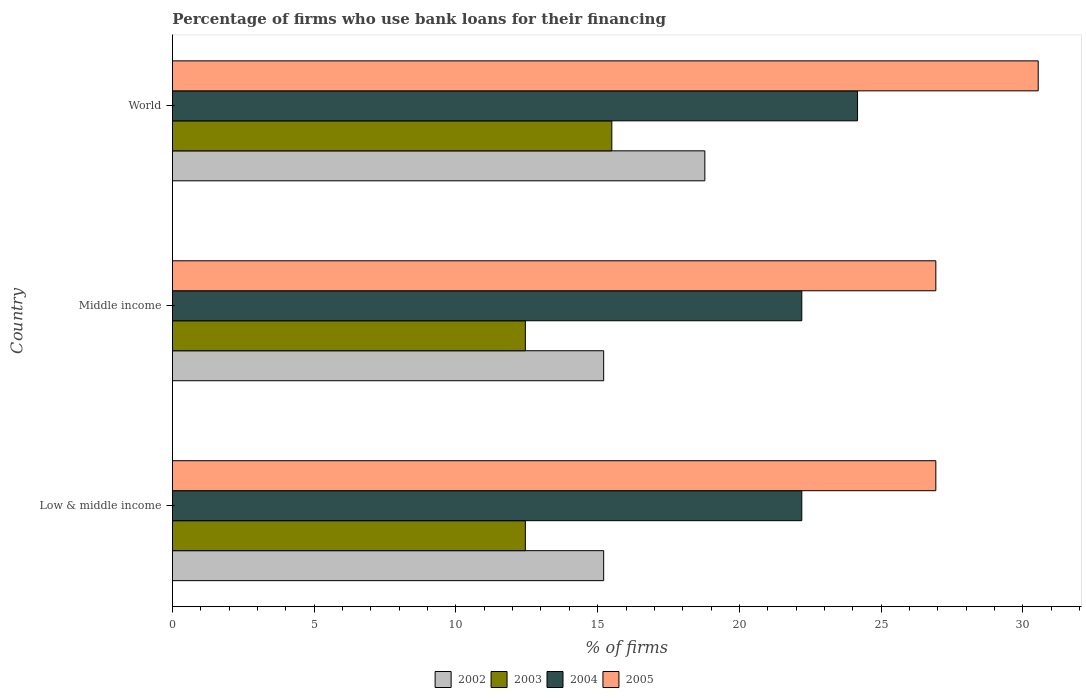How many different coloured bars are there?
Keep it short and to the point. 4. Are the number of bars per tick equal to the number of legend labels?
Provide a short and direct response. Yes. How many bars are there on the 1st tick from the top?
Provide a short and direct response. 4. What is the percentage of firms who use bank loans for their financing in 2003 in Low & middle income?
Offer a terse response. 12.45. Across all countries, what is the maximum percentage of firms who use bank loans for their financing in 2002?
Provide a succinct answer. 18.78. Across all countries, what is the minimum percentage of firms who use bank loans for their financing in 2004?
Offer a terse response. 22.2. In which country was the percentage of firms who use bank loans for their financing in 2003 minimum?
Keep it short and to the point. Low & middle income. What is the total percentage of firms who use bank loans for their financing in 2005 in the graph?
Ensure brevity in your answer.  84.39. What is the difference between the percentage of firms who use bank loans for their financing in 2004 in Middle income and that in World?
Keep it short and to the point. -1.97. What is the difference between the percentage of firms who use bank loans for their financing in 2002 in World and the percentage of firms who use bank loans for their financing in 2005 in Low & middle income?
Your response must be concise. -8.15. What is the average percentage of firms who use bank loans for their financing in 2002 per country?
Offer a very short reply. 16.4. What is the difference between the percentage of firms who use bank loans for their financing in 2003 and percentage of firms who use bank loans for their financing in 2005 in World?
Your answer should be compact. -15.04. Is the percentage of firms who use bank loans for their financing in 2004 in Low & middle income less than that in World?
Your response must be concise. Yes. Is the difference between the percentage of firms who use bank loans for their financing in 2003 in Middle income and World greater than the difference between the percentage of firms who use bank loans for their financing in 2005 in Middle income and World?
Your response must be concise. Yes. What is the difference between the highest and the second highest percentage of firms who use bank loans for their financing in 2003?
Provide a succinct answer. 3.05. What is the difference between the highest and the lowest percentage of firms who use bank loans for their financing in 2003?
Provide a succinct answer. 3.05. In how many countries, is the percentage of firms who use bank loans for their financing in 2005 greater than the average percentage of firms who use bank loans for their financing in 2005 taken over all countries?
Provide a short and direct response. 1. What does the 1st bar from the top in World represents?
Provide a short and direct response. 2005. Is it the case that in every country, the sum of the percentage of firms who use bank loans for their financing in 2002 and percentage of firms who use bank loans for their financing in 2005 is greater than the percentage of firms who use bank loans for their financing in 2003?
Keep it short and to the point. Yes. Are all the bars in the graph horizontal?
Your answer should be compact. Yes. Does the graph contain any zero values?
Provide a short and direct response. No. Does the graph contain grids?
Keep it short and to the point. No. Where does the legend appear in the graph?
Offer a terse response. Bottom center. How many legend labels are there?
Provide a succinct answer. 4. What is the title of the graph?
Your answer should be very brief. Percentage of firms who use bank loans for their financing. Does "1983" appear as one of the legend labels in the graph?
Keep it short and to the point. No. What is the label or title of the X-axis?
Offer a terse response. % of firms. What is the label or title of the Y-axis?
Keep it short and to the point. Country. What is the % of firms of 2002 in Low & middle income?
Your answer should be very brief. 15.21. What is the % of firms in 2003 in Low & middle income?
Your answer should be very brief. 12.45. What is the % of firms in 2005 in Low & middle income?
Your response must be concise. 26.93. What is the % of firms in 2002 in Middle income?
Provide a succinct answer. 15.21. What is the % of firms in 2003 in Middle income?
Your answer should be compact. 12.45. What is the % of firms in 2004 in Middle income?
Your response must be concise. 22.2. What is the % of firms of 2005 in Middle income?
Give a very brief answer. 26.93. What is the % of firms of 2002 in World?
Ensure brevity in your answer.  18.78. What is the % of firms of 2004 in World?
Give a very brief answer. 24.17. What is the % of firms of 2005 in World?
Your answer should be compact. 30.54. Across all countries, what is the maximum % of firms in 2002?
Ensure brevity in your answer.  18.78. Across all countries, what is the maximum % of firms of 2003?
Your answer should be very brief. 15.5. Across all countries, what is the maximum % of firms in 2004?
Your answer should be compact. 24.17. Across all countries, what is the maximum % of firms of 2005?
Give a very brief answer. 30.54. Across all countries, what is the minimum % of firms in 2002?
Ensure brevity in your answer.  15.21. Across all countries, what is the minimum % of firms of 2003?
Provide a short and direct response. 12.45. Across all countries, what is the minimum % of firms of 2005?
Make the answer very short. 26.93. What is the total % of firms of 2002 in the graph?
Make the answer very short. 49.21. What is the total % of firms in 2003 in the graph?
Your answer should be compact. 40.4. What is the total % of firms of 2004 in the graph?
Your answer should be very brief. 68.57. What is the total % of firms in 2005 in the graph?
Offer a very short reply. 84.39. What is the difference between the % of firms of 2003 in Low & middle income and that in Middle income?
Keep it short and to the point. 0. What is the difference between the % of firms of 2004 in Low & middle income and that in Middle income?
Provide a short and direct response. 0. What is the difference between the % of firms of 2002 in Low & middle income and that in World?
Offer a very short reply. -3.57. What is the difference between the % of firms in 2003 in Low & middle income and that in World?
Provide a short and direct response. -3.05. What is the difference between the % of firms of 2004 in Low & middle income and that in World?
Ensure brevity in your answer.  -1.97. What is the difference between the % of firms of 2005 in Low & middle income and that in World?
Ensure brevity in your answer.  -3.61. What is the difference between the % of firms of 2002 in Middle income and that in World?
Keep it short and to the point. -3.57. What is the difference between the % of firms of 2003 in Middle income and that in World?
Keep it short and to the point. -3.05. What is the difference between the % of firms in 2004 in Middle income and that in World?
Offer a very short reply. -1.97. What is the difference between the % of firms of 2005 in Middle income and that in World?
Offer a very short reply. -3.61. What is the difference between the % of firms in 2002 in Low & middle income and the % of firms in 2003 in Middle income?
Provide a succinct answer. 2.76. What is the difference between the % of firms in 2002 in Low & middle income and the % of firms in 2004 in Middle income?
Provide a succinct answer. -6.99. What is the difference between the % of firms in 2002 in Low & middle income and the % of firms in 2005 in Middle income?
Your answer should be compact. -11.72. What is the difference between the % of firms of 2003 in Low & middle income and the % of firms of 2004 in Middle income?
Make the answer very short. -9.75. What is the difference between the % of firms in 2003 in Low & middle income and the % of firms in 2005 in Middle income?
Offer a terse response. -14.48. What is the difference between the % of firms in 2004 in Low & middle income and the % of firms in 2005 in Middle income?
Keep it short and to the point. -4.73. What is the difference between the % of firms of 2002 in Low & middle income and the % of firms of 2003 in World?
Keep it short and to the point. -0.29. What is the difference between the % of firms in 2002 in Low & middle income and the % of firms in 2004 in World?
Provide a succinct answer. -8.95. What is the difference between the % of firms of 2002 in Low & middle income and the % of firms of 2005 in World?
Your answer should be compact. -15.33. What is the difference between the % of firms of 2003 in Low & middle income and the % of firms of 2004 in World?
Provide a succinct answer. -11.72. What is the difference between the % of firms in 2003 in Low & middle income and the % of firms in 2005 in World?
Keep it short and to the point. -18.09. What is the difference between the % of firms in 2004 in Low & middle income and the % of firms in 2005 in World?
Make the answer very short. -8.34. What is the difference between the % of firms of 2002 in Middle income and the % of firms of 2003 in World?
Ensure brevity in your answer.  -0.29. What is the difference between the % of firms in 2002 in Middle income and the % of firms in 2004 in World?
Ensure brevity in your answer.  -8.95. What is the difference between the % of firms of 2002 in Middle income and the % of firms of 2005 in World?
Keep it short and to the point. -15.33. What is the difference between the % of firms of 2003 in Middle income and the % of firms of 2004 in World?
Make the answer very short. -11.72. What is the difference between the % of firms of 2003 in Middle income and the % of firms of 2005 in World?
Your answer should be compact. -18.09. What is the difference between the % of firms of 2004 in Middle income and the % of firms of 2005 in World?
Keep it short and to the point. -8.34. What is the average % of firms of 2002 per country?
Keep it short and to the point. 16.4. What is the average % of firms of 2003 per country?
Give a very brief answer. 13.47. What is the average % of firms in 2004 per country?
Keep it short and to the point. 22.86. What is the average % of firms in 2005 per country?
Make the answer very short. 28.13. What is the difference between the % of firms in 2002 and % of firms in 2003 in Low & middle income?
Provide a short and direct response. 2.76. What is the difference between the % of firms of 2002 and % of firms of 2004 in Low & middle income?
Your answer should be very brief. -6.99. What is the difference between the % of firms in 2002 and % of firms in 2005 in Low & middle income?
Keep it short and to the point. -11.72. What is the difference between the % of firms of 2003 and % of firms of 2004 in Low & middle income?
Offer a terse response. -9.75. What is the difference between the % of firms of 2003 and % of firms of 2005 in Low & middle income?
Offer a very short reply. -14.48. What is the difference between the % of firms of 2004 and % of firms of 2005 in Low & middle income?
Your answer should be compact. -4.73. What is the difference between the % of firms in 2002 and % of firms in 2003 in Middle income?
Offer a very short reply. 2.76. What is the difference between the % of firms in 2002 and % of firms in 2004 in Middle income?
Offer a terse response. -6.99. What is the difference between the % of firms in 2002 and % of firms in 2005 in Middle income?
Provide a succinct answer. -11.72. What is the difference between the % of firms in 2003 and % of firms in 2004 in Middle income?
Keep it short and to the point. -9.75. What is the difference between the % of firms in 2003 and % of firms in 2005 in Middle income?
Ensure brevity in your answer.  -14.48. What is the difference between the % of firms of 2004 and % of firms of 2005 in Middle income?
Offer a terse response. -4.73. What is the difference between the % of firms in 2002 and % of firms in 2003 in World?
Offer a terse response. 3.28. What is the difference between the % of firms of 2002 and % of firms of 2004 in World?
Make the answer very short. -5.39. What is the difference between the % of firms of 2002 and % of firms of 2005 in World?
Offer a terse response. -11.76. What is the difference between the % of firms of 2003 and % of firms of 2004 in World?
Your response must be concise. -8.67. What is the difference between the % of firms of 2003 and % of firms of 2005 in World?
Your answer should be compact. -15.04. What is the difference between the % of firms in 2004 and % of firms in 2005 in World?
Keep it short and to the point. -6.37. What is the ratio of the % of firms in 2002 in Low & middle income to that in Middle income?
Your answer should be compact. 1. What is the ratio of the % of firms in 2004 in Low & middle income to that in Middle income?
Offer a very short reply. 1. What is the ratio of the % of firms of 2002 in Low & middle income to that in World?
Your response must be concise. 0.81. What is the ratio of the % of firms in 2003 in Low & middle income to that in World?
Keep it short and to the point. 0.8. What is the ratio of the % of firms of 2004 in Low & middle income to that in World?
Make the answer very short. 0.92. What is the ratio of the % of firms in 2005 in Low & middle income to that in World?
Ensure brevity in your answer.  0.88. What is the ratio of the % of firms of 2002 in Middle income to that in World?
Your answer should be compact. 0.81. What is the ratio of the % of firms in 2003 in Middle income to that in World?
Keep it short and to the point. 0.8. What is the ratio of the % of firms of 2004 in Middle income to that in World?
Your answer should be very brief. 0.92. What is the ratio of the % of firms of 2005 in Middle income to that in World?
Keep it short and to the point. 0.88. What is the difference between the highest and the second highest % of firms of 2002?
Offer a very short reply. 3.57. What is the difference between the highest and the second highest % of firms of 2003?
Keep it short and to the point. 3.05. What is the difference between the highest and the second highest % of firms of 2004?
Provide a succinct answer. 1.97. What is the difference between the highest and the second highest % of firms of 2005?
Provide a succinct answer. 3.61. What is the difference between the highest and the lowest % of firms of 2002?
Ensure brevity in your answer.  3.57. What is the difference between the highest and the lowest % of firms of 2003?
Offer a terse response. 3.05. What is the difference between the highest and the lowest % of firms in 2004?
Offer a terse response. 1.97. What is the difference between the highest and the lowest % of firms in 2005?
Your answer should be very brief. 3.61. 